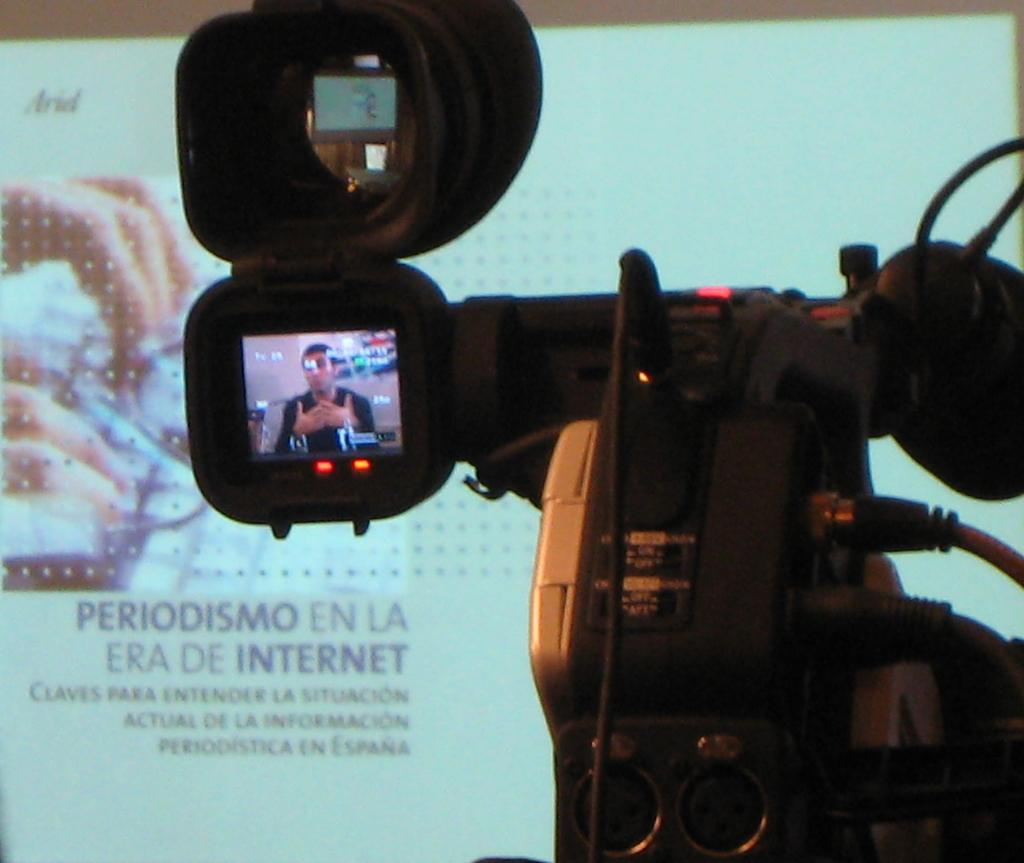What device is the main subject of the image? There is a video camera in the image. What can be seen on the camera display? A person is visible on the camera display. What is located in the background of the image? There is a projector screen in the background of the image. What is displayed on the projector screen? The projector screen displays text and a picture. What type of metal is used to construct the twig in the image? There is no twig present in the image, and therefore no metal construction can be observed. 